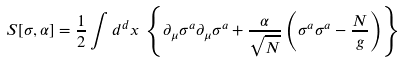Convert formula to latex. <formula><loc_0><loc_0><loc_500><loc_500>S [ \sigma , \alpha ] = \frac { 1 } { 2 } \int d ^ { d } x \, \left \{ \partial _ { \mu } \sigma ^ { a } \partial _ { \mu } \sigma ^ { a } + \frac { \alpha } { \sqrt { N } } \left ( \sigma ^ { a } \sigma ^ { a } - \frac { N } { g } \right ) \right \}</formula> 